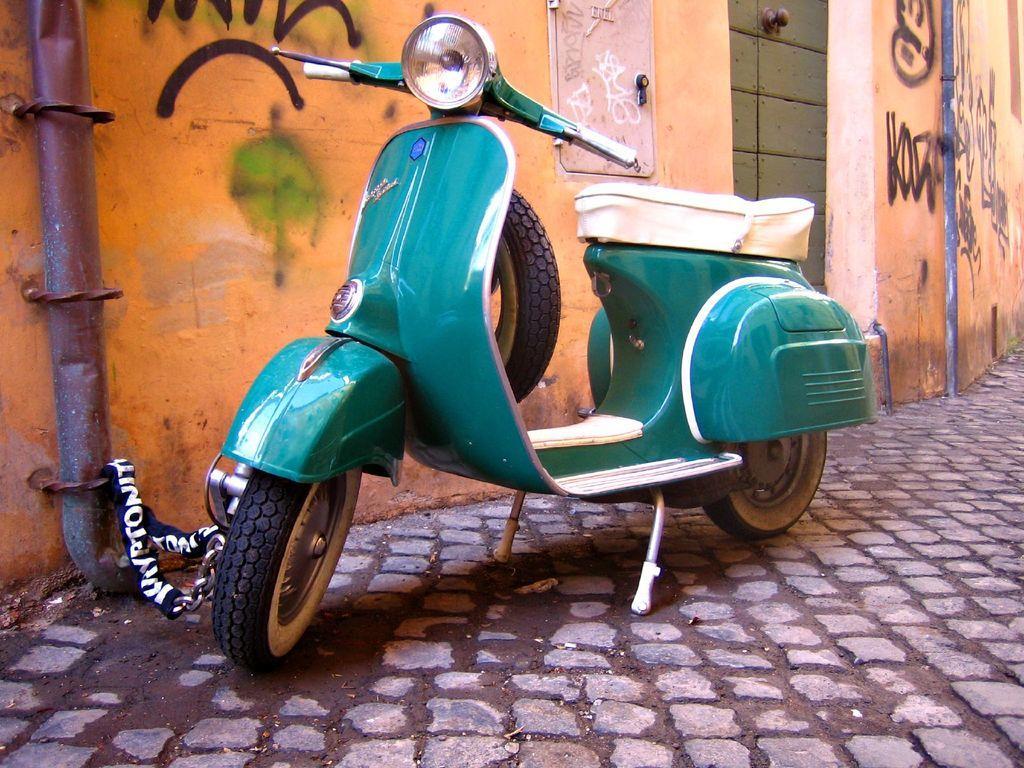How would you summarize this image in a sentence or two? In the image there is scooter on the footpath in front of the wall. 